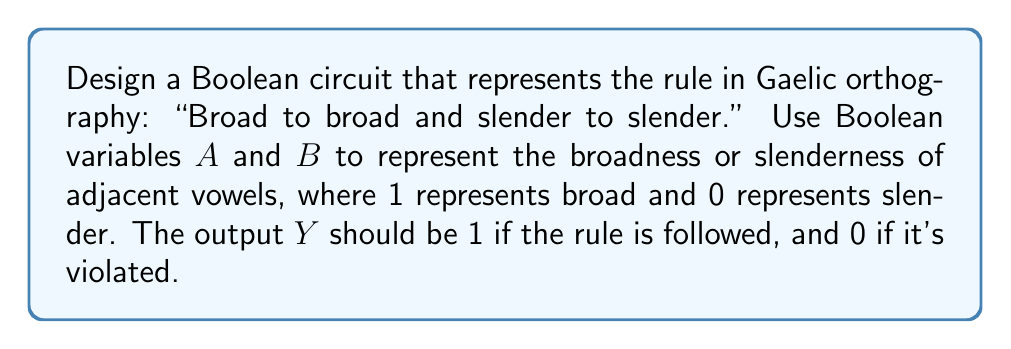Could you help me with this problem? To design this Boolean circuit, we need to follow these steps:

1. Define the variables:
   $A$: First vowel (1 for broad, 0 for slender)
   $B$: Second vowel (1 for broad, 0 for slender)
   $Y$: Output (1 if rule is followed, 0 if violated)

2. Create a truth table for all possible combinations:

   | $A$ | $B$ | $Y$ |
   |-----|-----|-----|
   | 0   | 0   | 1   |
   | 0   | 1   | 0   |
   | 1   | 0   | 0   |
   | 1   | 1   | 1   |

3. From the truth table, we can see that $Y$ is 1 when both $A$ and $B$ are 0 (slender to slender) or when both $A$ and $B$ are 1 (broad to broad).

4. This behavior can be represented by the Boolean expression:

   $Y = (A \cdot B) + (\overline{A} \cdot \overline{B})$

5. This expression can be implemented using AND gates, OR gates, and NOT gates:
   - Use a NOT gate for $\overline{A}$ and $\overline{B}$
   - Use two AND gates: one for $(A \cdot B)$ and one for $(\overline{A} \cdot \overline{B})$
   - Use an OR gate to combine the outputs of the AND gates

6. The resulting circuit can be represented as follows:

[asy]
import geometry;

// Define points
pair A = (0,0), B = (0,30), N1 = (20,0), N2 = (20,30);
pair AND1 = (50,15), AND2 = (50,45), OR = (90,30);
pair Y = (120,30);

// Draw NOT gates
draw(A--N1, arrow=Arrow(SimpleHead));
draw(B--N2, arrow=Arrow(SimpleHead));
draw(circle(N1,5));
draw(circle(N2,5));

// Draw AND gates
path and1 = (40,10)--(60,10)--(60,20)--(40,20)--cycle;
fill(and1, gray(0.9));
draw(and1);
draw(arc((50,15),10,270,90));

path and2 = (40,40)--(60,40)--(60,50)--(40,50)--cycle;
fill(and2, gray(0.9));
draw(and2);
draw(arc((50,45),10,270,90));

// Draw OR gate
path or = (80,20)--(100,20)--(100,40)--(80,40)--cycle;
fill(or, gray(0.9));
draw(or);
draw(arc((85,30),15,300,60));

// Connect gates
draw(N1--(40,10), arrow=Arrow(SimpleHead));
draw(N2--(40,50), arrow=Arrow(SimpleHead));
draw(A--(40,20), arrow=Arrow(SimpleHead));
draw(B--(40,40), arrow=Arrow(SimpleHead));
draw((60,15)--(80,25), arrow=Arrow(SimpleHead));
draw((60,45)--(80,35), arrow=Arrow(SimpleHead));
draw(OR--Y, arrow=Arrow(SimpleHead));

// Label points
label("$A$", A, W);
label("$B$", B, W);
label("$Y$", Y, E);
[/asy]

This circuit implements the Boolean function that represents the "Broad to broad and slender to slender" rule in Gaelic orthography.
Answer: $Y = (A \cdot B) + (\overline{A} \cdot \overline{B})$ 